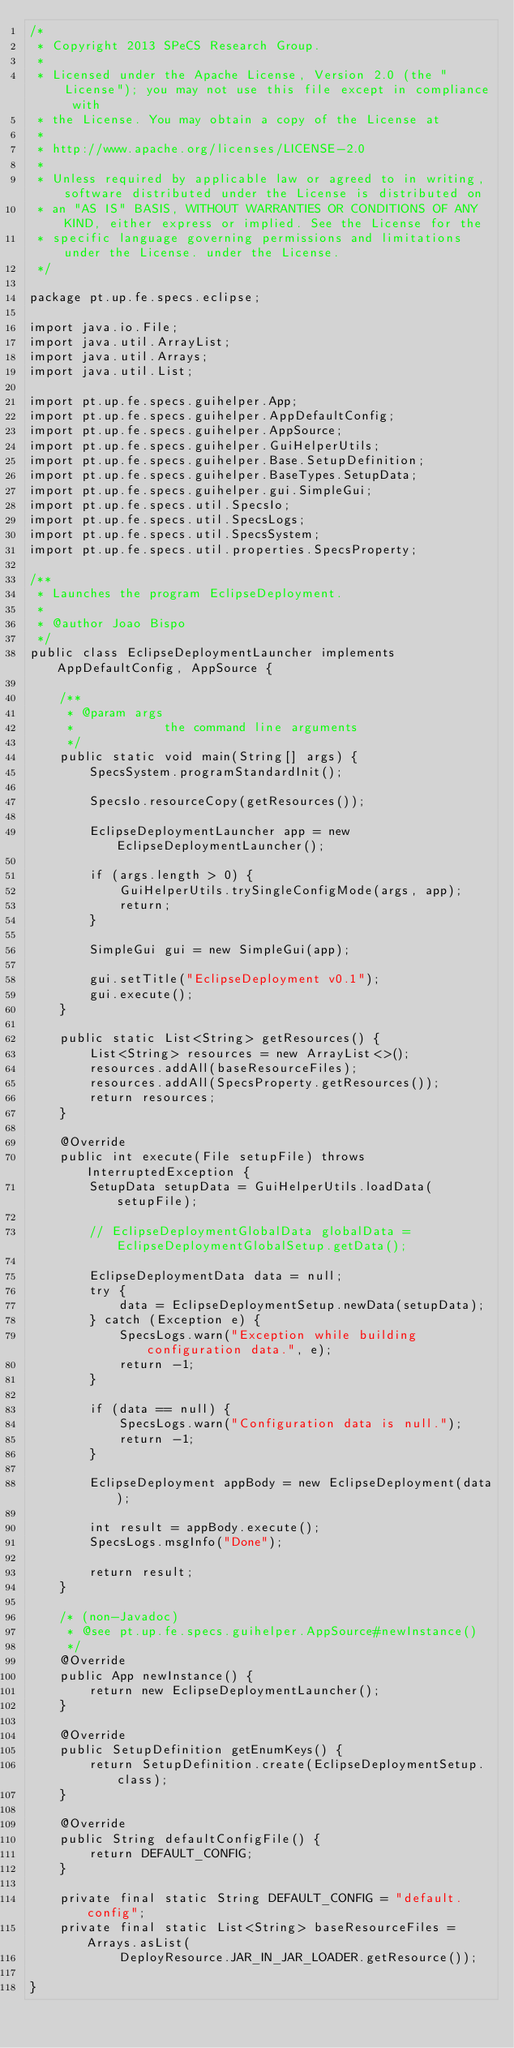Convert code to text. <code><loc_0><loc_0><loc_500><loc_500><_Java_>/*
 * Copyright 2013 SPeCS Research Group.
 * 
 * Licensed under the Apache License, Version 2.0 (the "License"); you may not use this file except in compliance with
 * the License. You may obtain a copy of the License at
 * 
 * http://www.apache.org/licenses/LICENSE-2.0
 * 
 * Unless required by applicable law or agreed to in writing, software distributed under the License is distributed on
 * an "AS IS" BASIS, WITHOUT WARRANTIES OR CONDITIONS OF ANY KIND, either express or implied. See the License for the
 * specific language governing permissions and limitations under the License. under the License.
 */

package pt.up.fe.specs.eclipse;

import java.io.File;
import java.util.ArrayList;
import java.util.Arrays;
import java.util.List;

import pt.up.fe.specs.guihelper.App;
import pt.up.fe.specs.guihelper.AppDefaultConfig;
import pt.up.fe.specs.guihelper.AppSource;
import pt.up.fe.specs.guihelper.GuiHelperUtils;
import pt.up.fe.specs.guihelper.Base.SetupDefinition;
import pt.up.fe.specs.guihelper.BaseTypes.SetupData;
import pt.up.fe.specs.guihelper.gui.SimpleGui;
import pt.up.fe.specs.util.SpecsIo;
import pt.up.fe.specs.util.SpecsLogs;
import pt.up.fe.specs.util.SpecsSystem;
import pt.up.fe.specs.util.properties.SpecsProperty;

/**
 * Launches the program EclipseDeployment.
 * 
 * @author Joao Bispo
 */
public class EclipseDeploymentLauncher implements AppDefaultConfig, AppSource {

    /**
     * @param args
     *            the command line arguments
     */
    public static void main(String[] args) {
        SpecsSystem.programStandardInit();

        SpecsIo.resourceCopy(getResources());

        EclipseDeploymentLauncher app = new EclipseDeploymentLauncher();

        if (args.length > 0) {
            GuiHelperUtils.trySingleConfigMode(args, app);
            return;
        }

        SimpleGui gui = new SimpleGui(app);

        gui.setTitle("EclipseDeployment v0.1");
        gui.execute();
    }

    public static List<String> getResources() {
        List<String> resources = new ArrayList<>();
        resources.addAll(baseResourceFiles);
        resources.addAll(SpecsProperty.getResources());
        return resources;
    }

    @Override
    public int execute(File setupFile) throws InterruptedException {
        SetupData setupData = GuiHelperUtils.loadData(setupFile);

        // EclipseDeploymentGlobalData globalData = EclipseDeploymentGlobalSetup.getData();

        EclipseDeploymentData data = null;
        try {
            data = EclipseDeploymentSetup.newData(setupData);
        } catch (Exception e) {
            SpecsLogs.warn("Exception while building configuration data.", e);
            return -1;
        }

        if (data == null) {
            SpecsLogs.warn("Configuration data is null.");
            return -1;
        }

        EclipseDeployment appBody = new EclipseDeployment(data);

        int result = appBody.execute();
        SpecsLogs.msgInfo("Done");

        return result;
    }

    /* (non-Javadoc)
     * @see pt.up.fe.specs.guihelper.AppSource#newInstance()
     */
    @Override
    public App newInstance() {
        return new EclipseDeploymentLauncher();
    }

    @Override
    public SetupDefinition getEnumKeys() {
        return SetupDefinition.create(EclipseDeploymentSetup.class);
    }

    @Override
    public String defaultConfigFile() {
        return DEFAULT_CONFIG;
    }

    private final static String DEFAULT_CONFIG = "default.config";
    private final static List<String> baseResourceFiles = Arrays.asList(
            DeployResource.JAR_IN_JAR_LOADER.getResource());

}</code> 